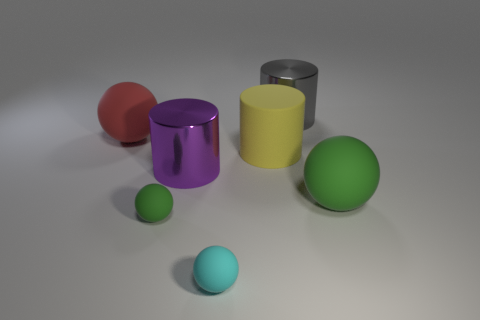Subtract all tiny green spheres. How many spheres are left? 3 Subtract 2 cylinders. How many cylinders are left? 1 Subtract all cylinders. How many objects are left? 4 Add 1 tiny green metallic cylinders. How many objects exist? 8 Subtract all cyan balls. How many balls are left? 3 Subtract all gray spheres. Subtract all purple cubes. How many spheres are left? 4 Subtract all green balls. How many yellow cylinders are left? 1 Subtract all cylinders. Subtract all large metal things. How many objects are left? 2 Add 7 large yellow objects. How many large yellow objects are left? 8 Add 2 brown rubber cubes. How many brown rubber cubes exist? 2 